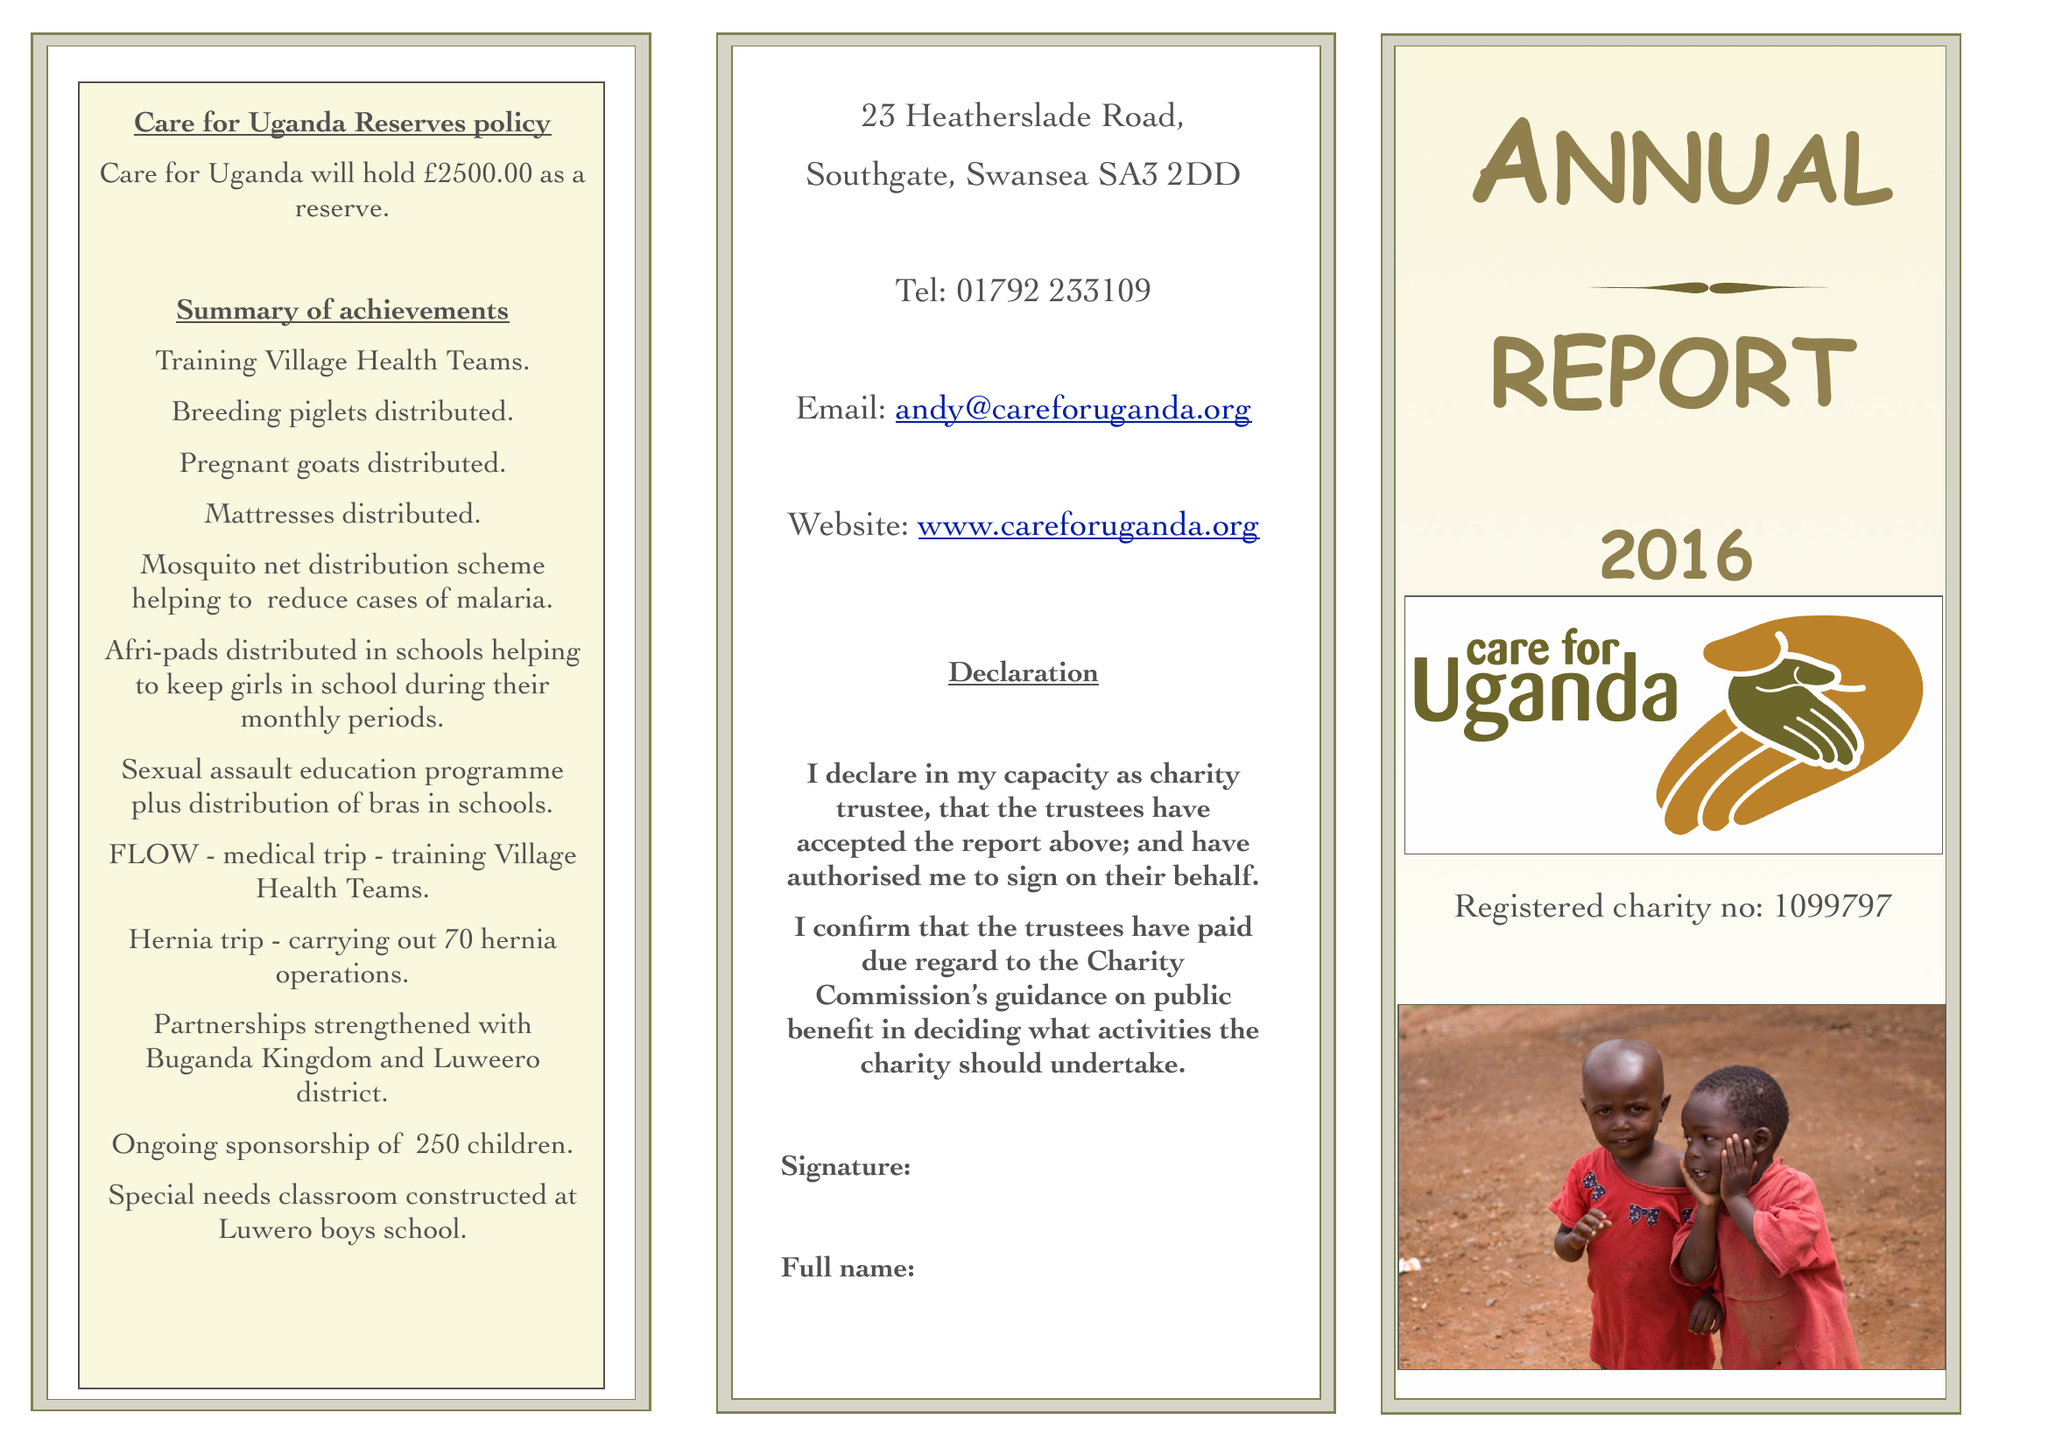What is the value for the income_annually_in_british_pounds?
Answer the question using a single word or phrase. 187409.00 